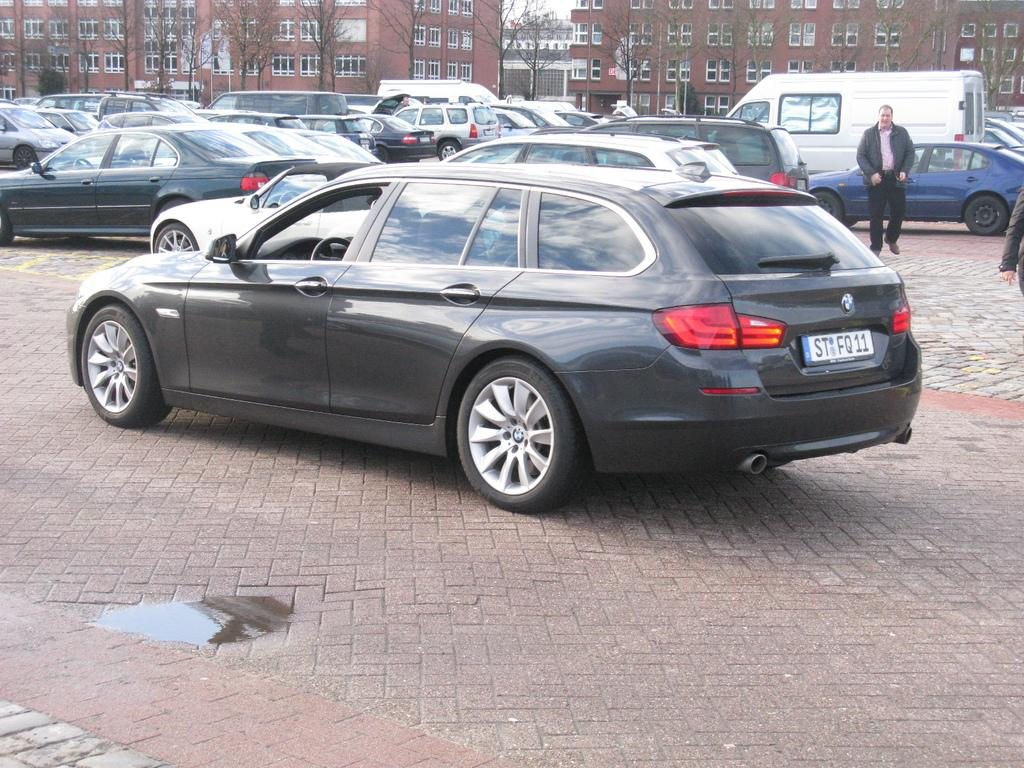What can be seen in the image related to transportation? There are vehicles in the image. What is the condition of the ground in the image? There is water on the ground in the image. Can you describe the people in the image? There are two persons on the right side of the image. What is visible in the background behind the vehicles? There are trees and buildings visible behind the vehicles. What degree of difficulty is the frame of the image rated? The image does not have a degree of difficulty rating, as it is a static representation and not a challenge or task. 